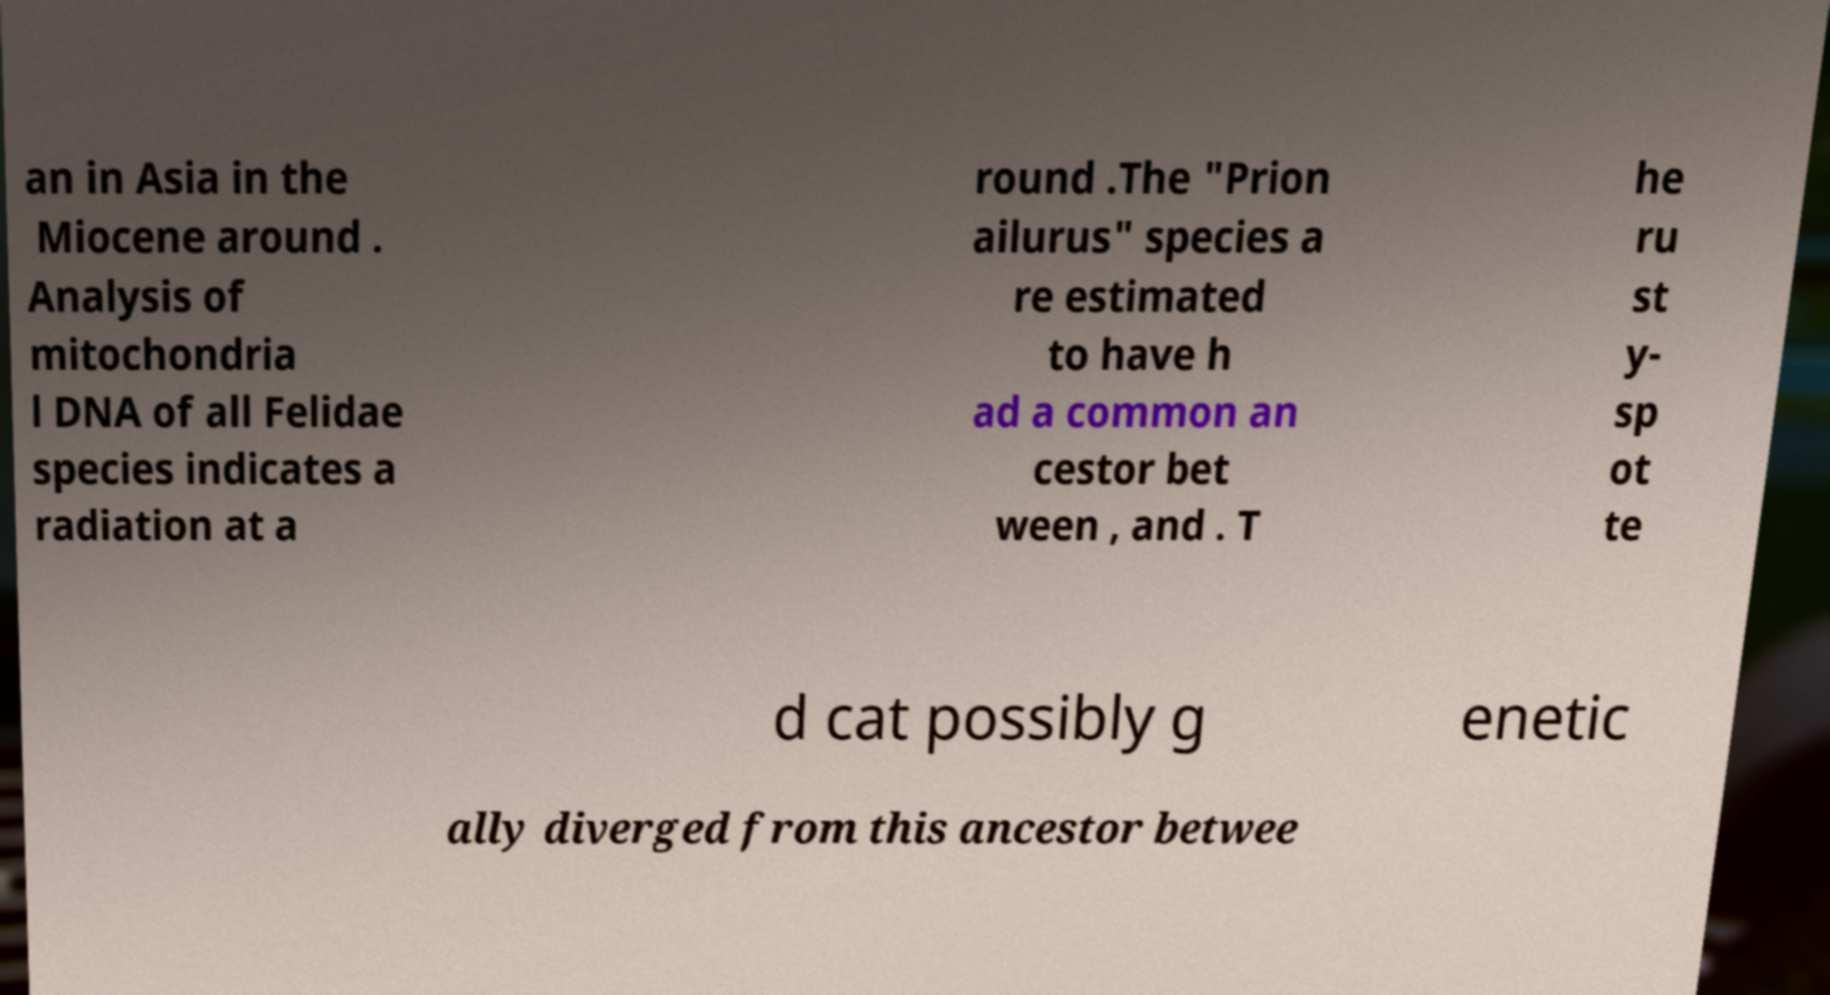Can you read and provide the text displayed in the image?This photo seems to have some interesting text. Can you extract and type it out for me? an in Asia in the Miocene around . Analysis of mitochondria l DNA of all Felidae species indicates a radiation at a round .The "Prion ailurus" species a re estimated to have h ad a common an cestor bet ween , and . T he ru st y- sp ot te d cat possibly g enetic ally diverged from this ancestor betwee 